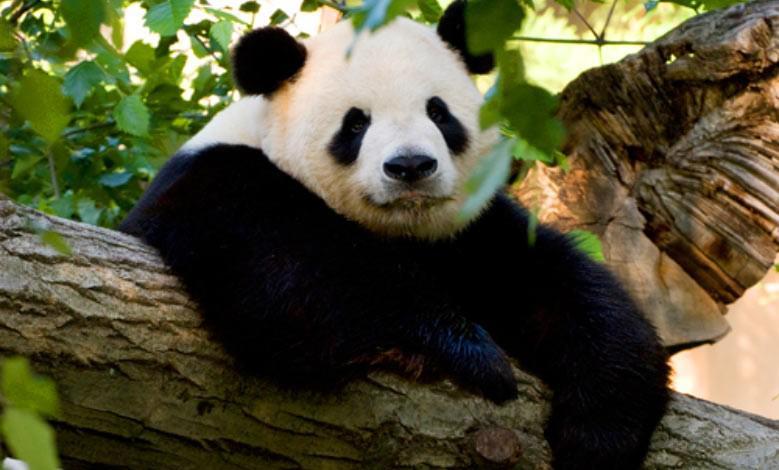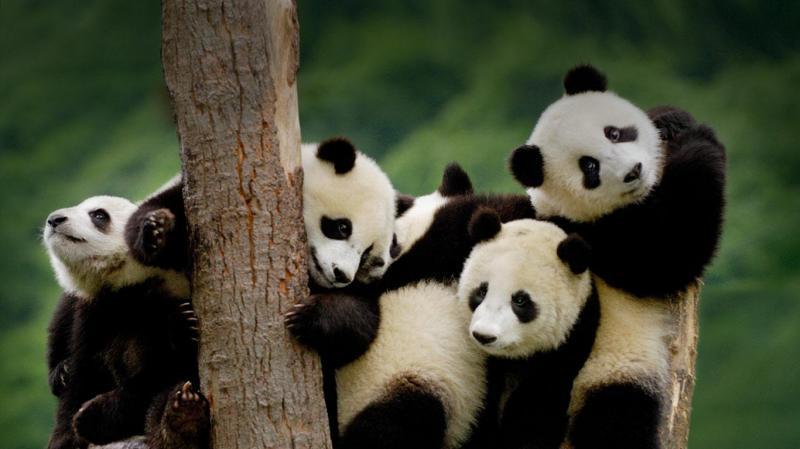The first image is the image on the left, the second image is the image on the right. Assess this claim about the two images: "The right image contains exactly two pandas.". Correct or not? Answer yes or no. No. The first image is the image on the left, the second image is the image on the right. For the images displayed, is the sentence "One image shows at least one panda on top of bright yellow plastic playground equipment." factually correct? Answer yes or no. No. 